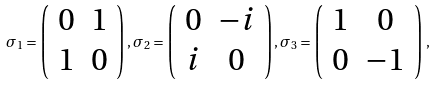<formula> <loc_0><loc_0><loc_500><loc_500>\sigma _ { 1 } = \left ( \begin{array} { c c } 0 & 1 \\ 1 & 0 \end{array} \right ) , \sigma _ { 2 } = \left ( \begin{array} { c c } 0 & - i \\ i & 0 \end{array} \right ) , \sigma _ { 3 } = \left ( \begin{array} { c c } 1 & 0 \\ 0 & - 1 \end{array} \right ) \, ,</formula> 